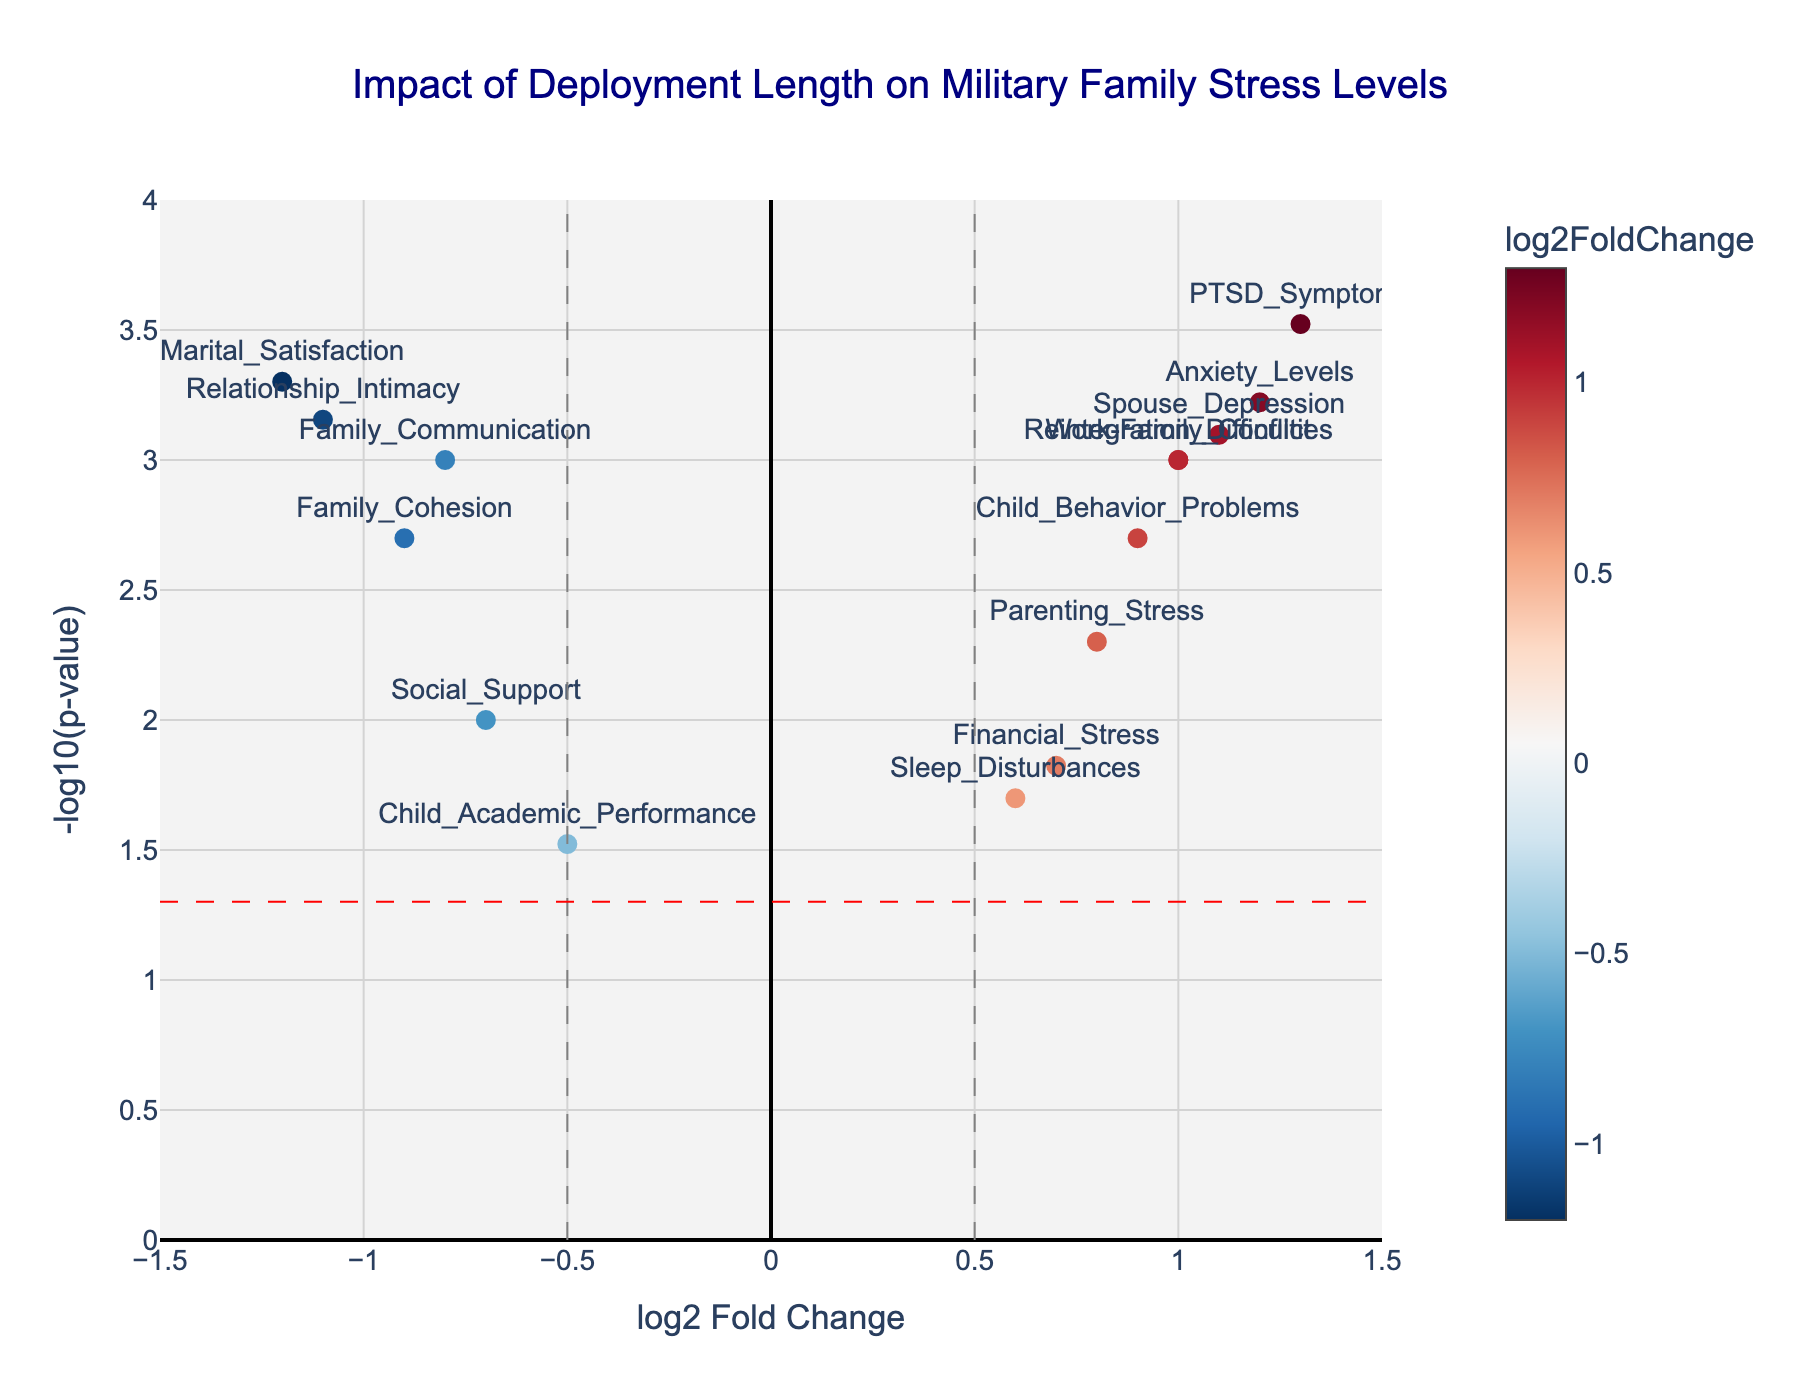What is the title of the plot? Look at the top of the plot to find the title. The title is usually the most prominent text, often larger and centered.
Answer: Impact of Deployment Length on Military Family Stress Levels What do the x-axis and y-axis represent? Examine the labels of the x-axis and y-axis. The x-axis is typically at the bottom, and the y-axis is on the left side of the plot.
Answer: x-axis: log2 Fold Change, y-axis: -log10(p-value) How many data points are more significant than the p-value threshold? Look at the horizontal red dashed line representing the p-value threshold. Count the number of points above this line.
Answer: 12 Which data point has the highest -log10(p-value)? Identify the data point that has the highest position on the y-axis.
Answer: PTSD_Symptoms Which stress factor has the most negative log2 Fold Change? Locate the data point farthest to the left on the x-axis for the most negative log2 Fold Change.
Answer: Marital_Satisfaction What is the log2 Fold Change and p-value of Family_Communication? Hover over or examine the position of Family_Communication on the plot. The precise values are usually provided in a hover text.
Answer: log2 Fold Change: -0.8, p-value: 0.001 How many stress factors are less significant (p-value above the threshold)? Count the number of points below the horizontal red dashed line, indicating p-values above the threshold.
Answer: 3 Which stress factor shows the most significant positive change? Find the point farthest to the right and highest on the plot. This indicates the most positive log2 Fold Change and lowest p-value.
Answer: PTSD_Symptoms Is Family_Cohesion significantly affected by deployment length? Check Family_Cohesion's position relative to the horizontal red dashed line. Points above this line indicate significant values.
Answer: Yes What does the color of the data points indicate? Observe the color scale provided on the plot. The color of the points usually represents the magnitude of the log2 Fold Change.
Answer: The log2 Fold Change value 